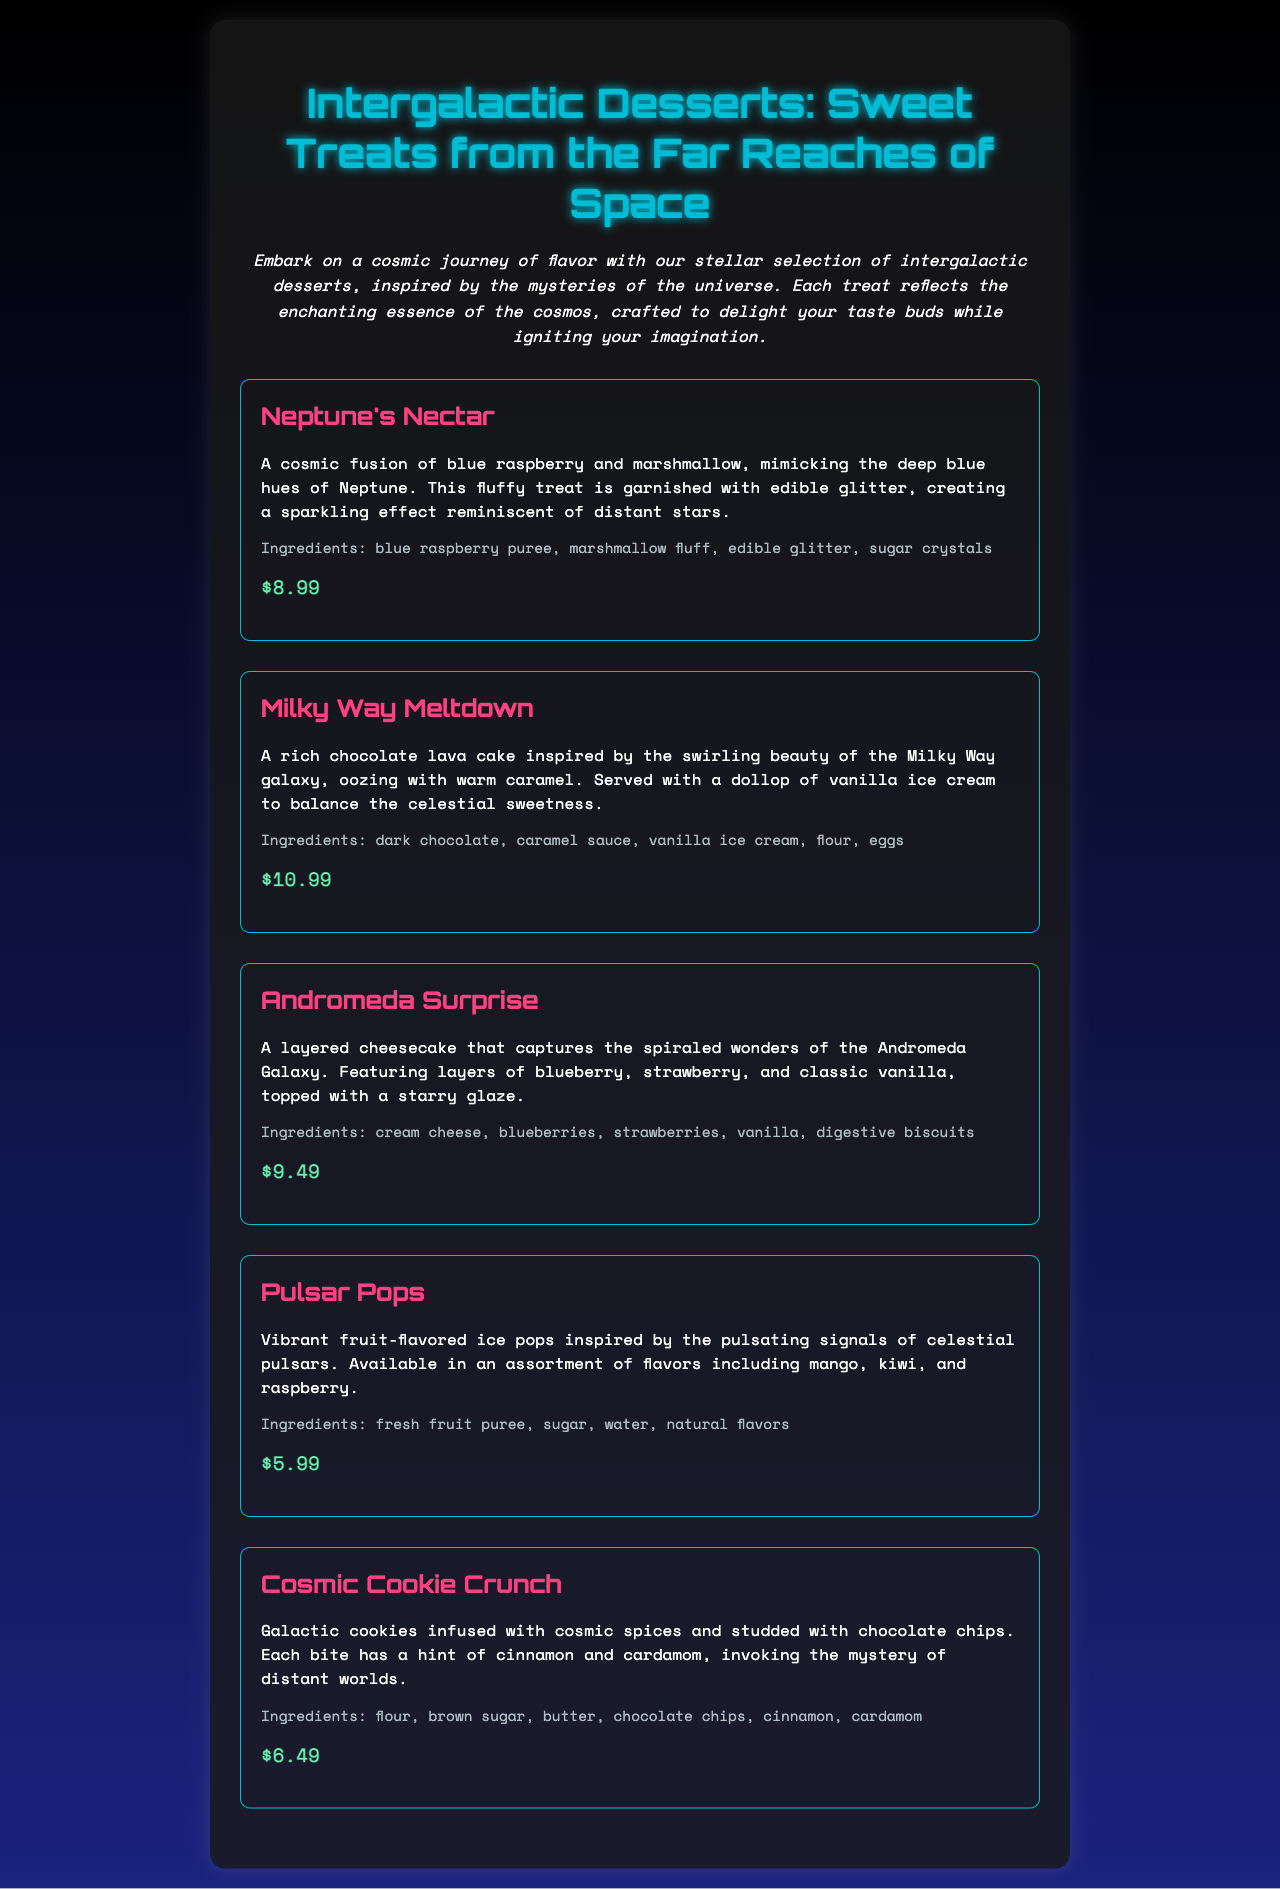What is the name of the dessert inspired by blue raspberry? The dessert that features blue raspberry is Neptune's Nectar.
Answer: Neptune's Nectar How much does the Milky Way Meltdown cost? The price of the Milky Way Meltdown is clearly mentioned in the menu.
Answer: $10.99 What ingredients are in the Andromeda Surprise? The ingredients of the Andromeda Surprise are listed directly under the dessert description.
Answer: cream cheese, blueberries, strawberries, vanilla, digestive biscuits Which dessert is inspired by the signals of celestial pulsars? The Pulsar Pops dessert is explicitly described as inspired by pulsars.
Answer: Pulsar Pops What are the flavors available for Pulsar Pops? The menu specifies the flavors that Pulsar Pops come in.
Answer: mango, kiwi, raspberry How many desserts are listed on the menu? The total number of desserts can be counted from the document.
Answer: 5 Which dessert has a hint of cinnamon and cardamom? The Cosmic Cookie Crunch is described to have these spices.
Answer: Cosmic Cookie Crunch What type of cake is the Milky Way Meltdown? The Milky Way Meltdown is characterized as a specific type of cake in the description.
Answer: chocolate lava cake What color is Neptune's Nectar primarily associated with? The primary color associated with Neptune's Nectar is highlighted in the description.
Answer: blue 